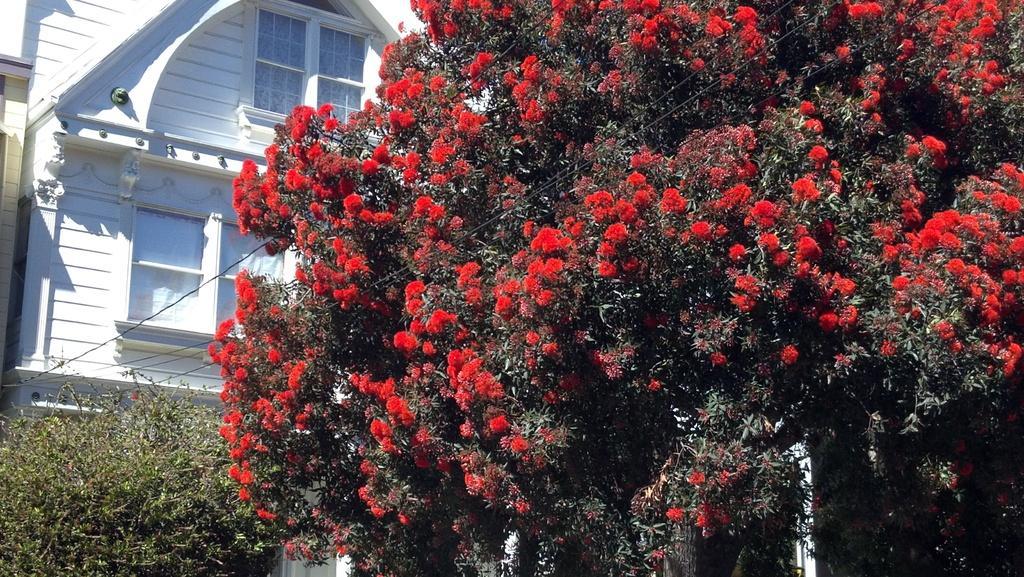How would you summarize this image in a sentence or two? In the picture I can see trees with red color flowers, I can see the shrubs and the white color house in the background. 